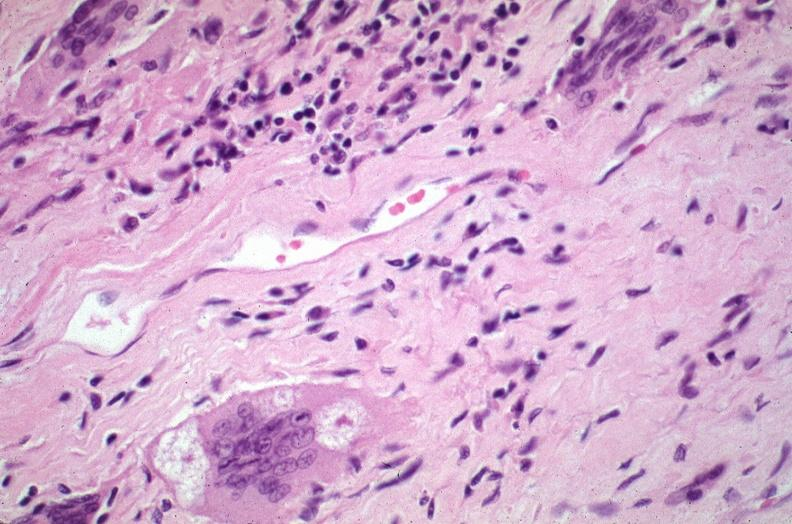what is present?
Answer the question using a single word or phrase. Respiratory 